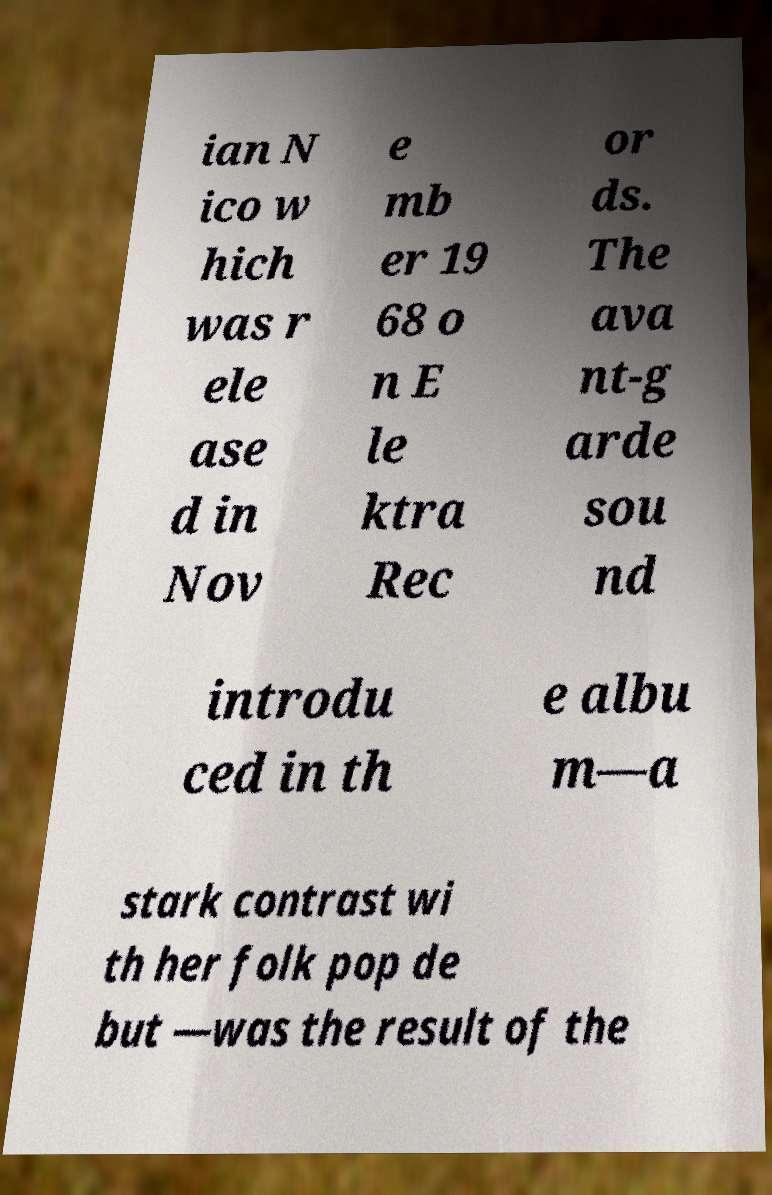Can you accurately transcribe the text from the provided image for me? ian N ico w hich was r ele ase d in Nov e mb er 19 68 o n E le ktra Rec or ds. The ava nt-g arde sou nd introdu ced in th e albu m—a stark contrast wi th her folk pop de but —was the result of the 